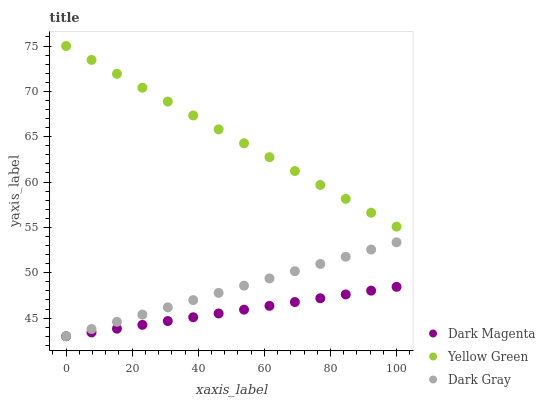Does Dark Magenta have the minimum area under the curve?
Answer yes or no. Yes. Does Yellow Green have the maximum area under the curve?
Answer yes or no. Yes. Does Yellow Green have the minimum area under the curve?
Answer yes or no. No. Does Dark Magenta have the maximum area under the curve?
Answer yes or no. No. Is Dark Magenta the smoothest?
Answer yes or no. Yes. Is Dark Gray the roughest?
Answer yes or no. Yes. Is Yellow Green the smoothest?
Answer yes or no. No. Is Yellow Green the roughest?
Answer yes or no. No. Does Dark Gray have the lowest value?
Answer yes or no. Yes. Does Yellow Green have the lowest value?
Answer yes or no. No. Does Yellow Green have the highest value?
Answer yes or no. Yes. Does Dark Magenta have the highest value?
Answer yes or no. No. Is Dark Magenta less than Yellow Green?
Answer yes or no. Yes. Is Yellow Green greater than Dark Magenta?
Answer yes or no. Yes. Does Dark Magenta intersect Dark Gray?
Answer yes or no. Yes. Is Dark Magenta less than Dark Gray?
Answer yes or no. No. Is Dark Magenta greater than Dark Gray?
Answer yes or no. No. Does Dark Magenta intersect Yellow Green?
Answer yes or no. No. 